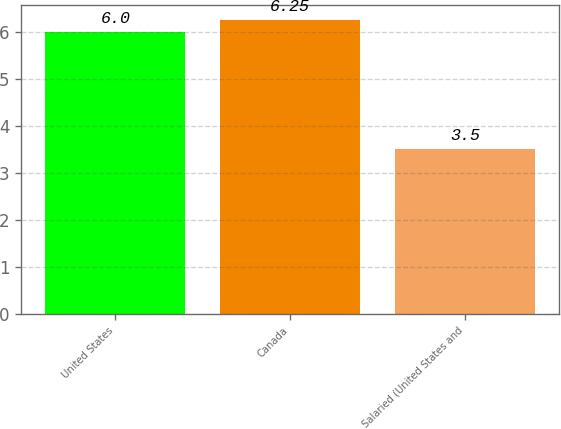Convert chart. <chart><loc_0><loc_0><loc_500><loc_500><bar_chart><fcel>United States<fcel>Canada<fcel>Salaried (United States and<nl><fcel>6<fcel>6.25<fcel>3.5<nl></chart> 